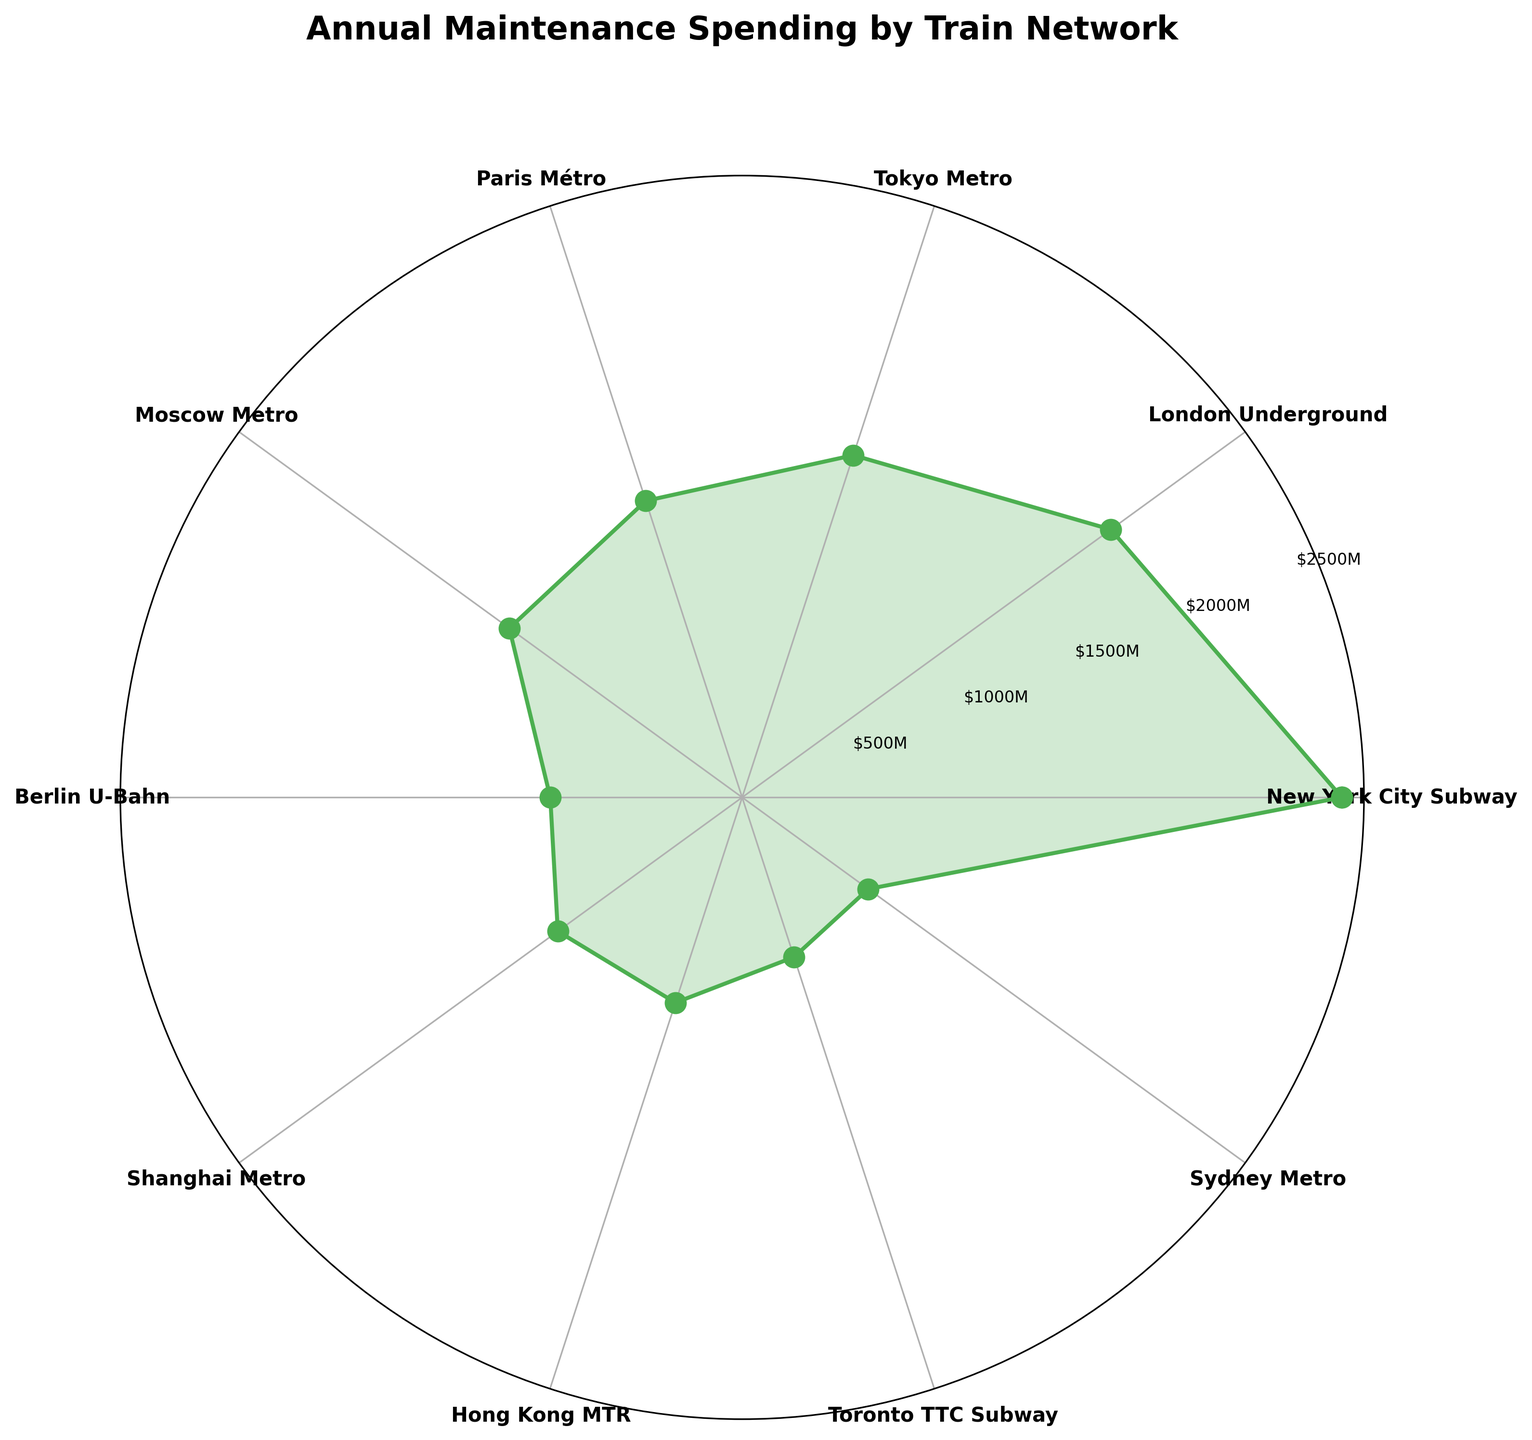What is the title of the figure? The title is prominently displayed at the top of the figure in bold text.
Answer: Annual Maintenance Spending by Train Network Which train network has the highest annual maintenance spending? By examining the lengths of the lines radiating from the center of the polar chart, the data point furthest from the center represents the highest value.
Answer: New York City Subway How much is the annual maintenance spending of the Berlin U-Bahn? Find the label for Berlin U-Bahn on the polar plot and read the corresponding value along the radial direction.
Answer: 800 million USD What is the total maintenance spending of Tokyo Metro and Moscow Metro combined? Look at the spending values for Tokyo Metro and Moscow Metro and add them together: 1500 (Tokyo Metro) + 1200 (Moscow Metro) = 2700.
Answer: 2700 million USD Compare the maintenance spending of the London Underground and the Paris Métro. Which one spends more? Identify the spending values for London Underground and Paris Métro. Compare them directly: 1900 (London Underground) is greater than 1300 (Paris Métro).
Answer: London Underground What is the median annual maintenance spending among all train networks listed? Arrange the spending values in ascending order and find the middle value. Here, the data in ascending order is: 650, 700, 800, 900, 950, 1200, 1300, 1500, 1900, 2500. The median value is the average of the 5th and 6th values: (950+1200)/2 = 1075.
Answer: 1075 million USD Which train network’s maintenance spending is closest to 1000 million USD? Check the values that are near 1000 million USD and compare distances. Shanghai Metro has a spending of 950 million USD, which is closest.
Answer: Shanghai Metro What is the average annual maintenance spending across all the train networks? Sum all the spending values: 2500 + 1900 + 1500 + 1300 + 1200 + 800 + 950 + 900 + 700 + 650 = 12400. Then, divide by the number of networks: 12400 / 10 = 1240.
Answer: 1240 million USD Which three train networks have the least annual maintenance spending? Compare all values and list the three smallest ones: 650 (Sydney Metro), 700 (Toronto TTC Subway), 800 (Berlin U-Bahn).
Answer: Sydney Metro, Toronto TTC Subway, Berlin U-Bahn By how much does the annual maintenance spending of the New York City Subway surpass that of the Hong Kong MTR? Subtract the spending of Hong Kong MTR from that of the New York City Subway: 2500 (New York City Subway) - 900 (Hong Kong MTR) = 1600.
Answer: 1600 million USD 